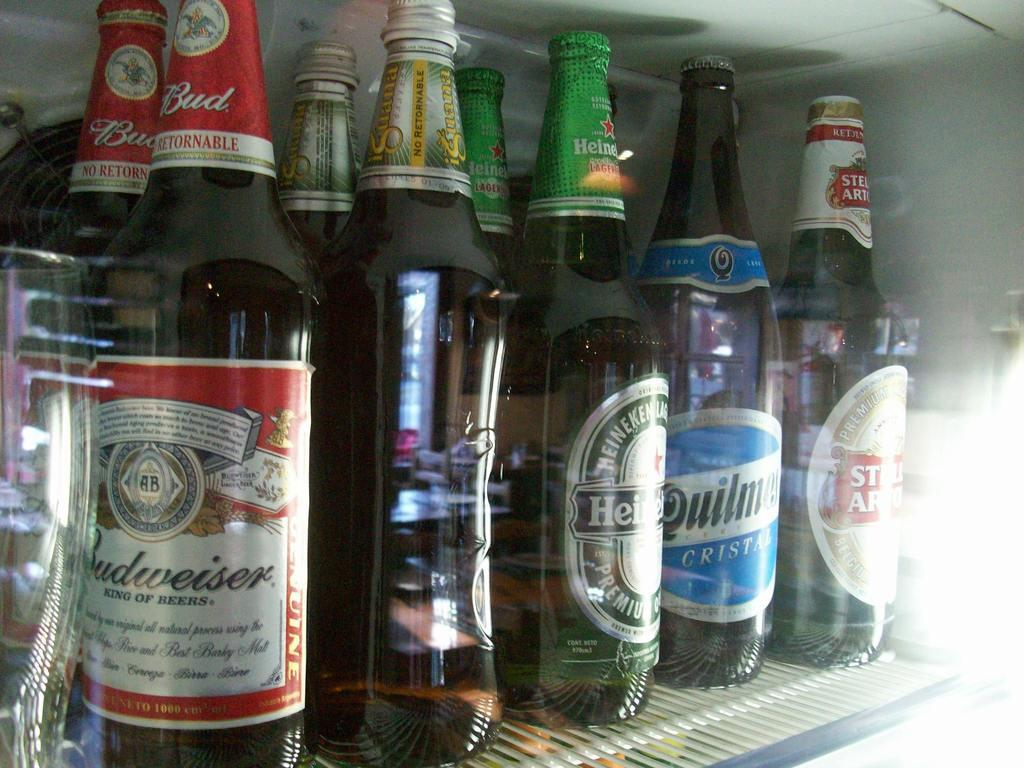<image>
Summarize the visual content of the image. Refrigerator with Budweiser, Heineken, iQuana, Quilman and Sella Artolis beer 